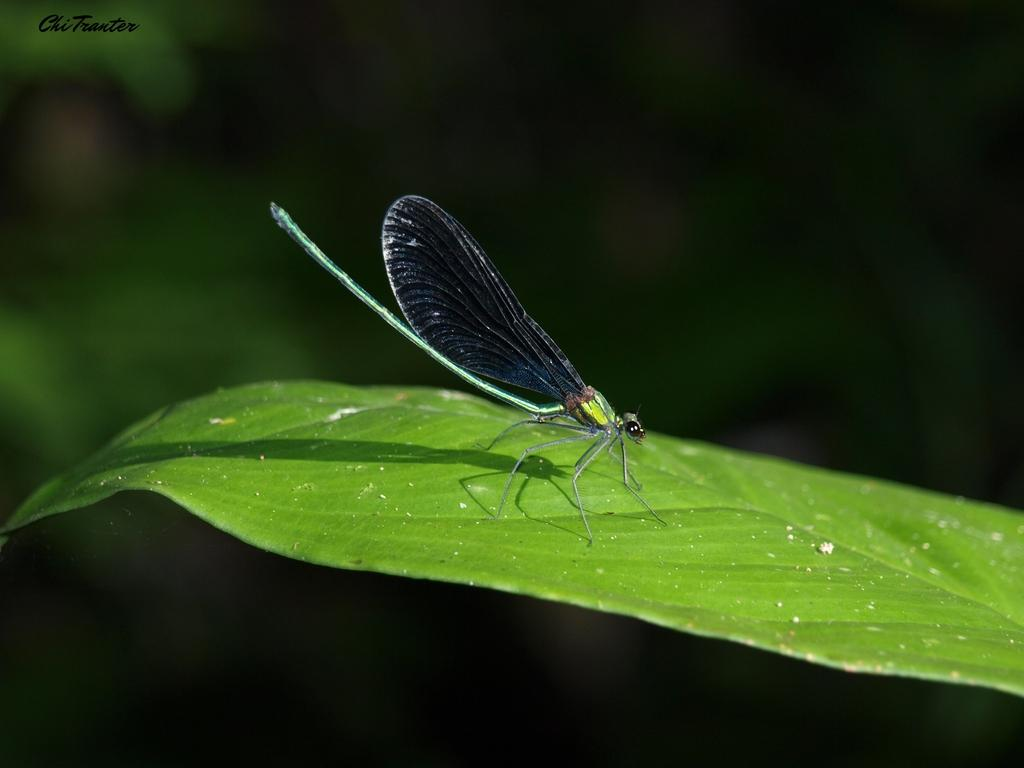What insect can be seen in the image? There is a dragonfly on a green leaf in the image. What is the color of the leaf the dragonfly is on? The leaf is green. How would you describe the clarity of the image? The image is blurry at the back. Where is the text located in the image? The text is at the top left of the image. What level of cough medicine is recommended for the dragonfly in the image? There is no mention of cough medicine or a coughing dragonfly in the image. 